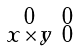<formula> <loc_0><loc_0><loc_500><loc_500>\begin{smallmatrix} 0 & 0 \\ x \times y & 0 \end{smallmatrix}</formula> 